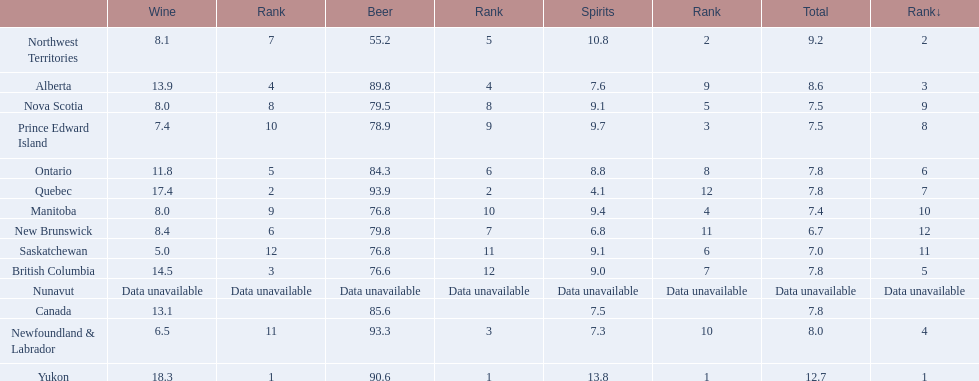What is the first ranked alcoholic beverage in canada Yukon. How many litters is consumed a year? 12.7. 